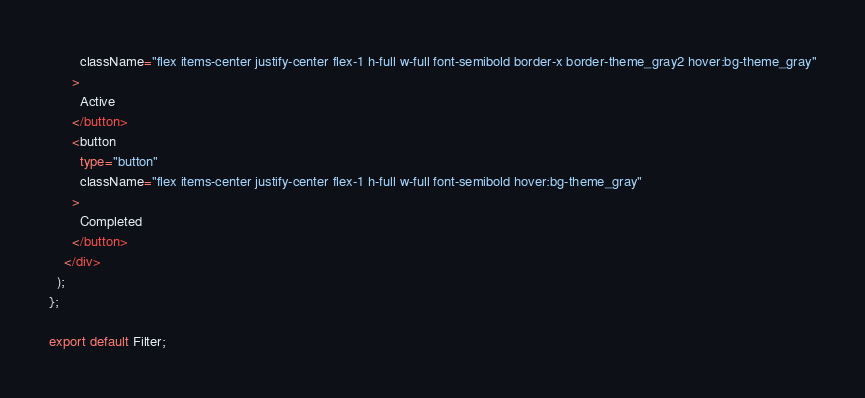<code> <loc_0><loc_0><loc_500><loc_500><_TypeScript_>        className="flex items-center justify-center flex-1 h-full w-full font-semibold border-x border-theme_gray2 hover:bg-theme_gray"
      >
        Active
      </button>
      <button
        type="button"
        className="flex items-center justify-center flex-1 h-full w-full font-semibold hover:bg-theme_gray"
      >
        Completed
      </button>
    </div>
  );
};

export default Filter;
</code> 